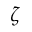<formula> <loc_0><loc_0><loc_500><loc_500>\zeta</formula> 